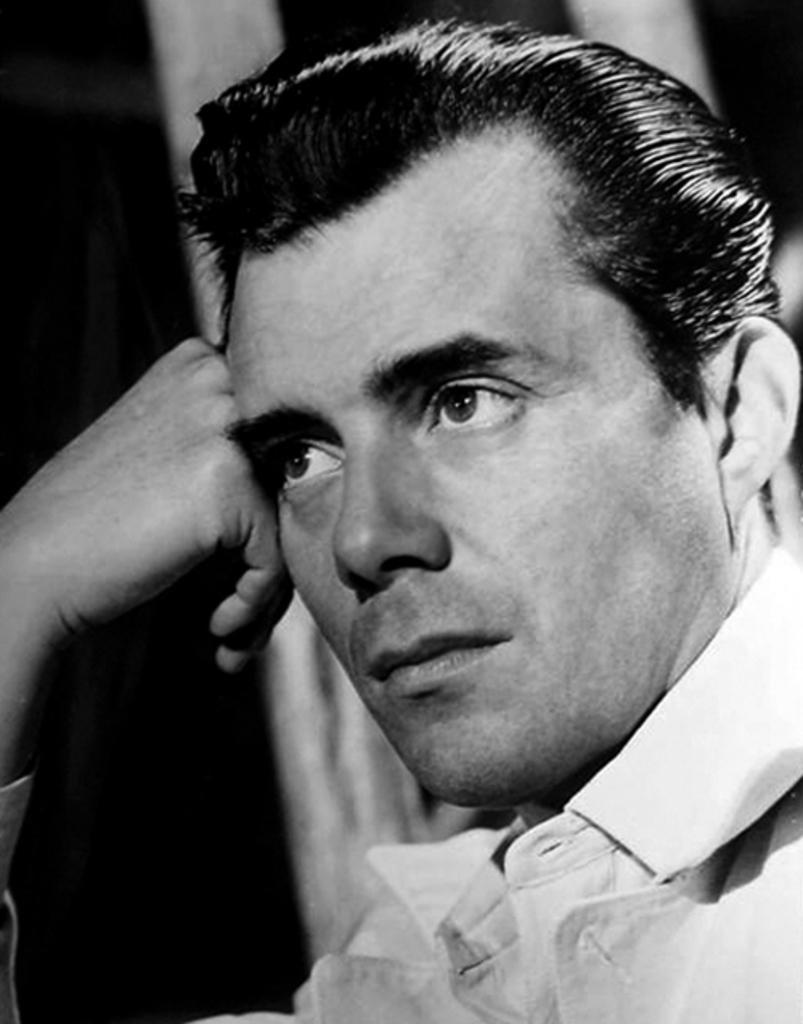Please provide a concise description of this image. In this picture we can see a man who is wearing shirt. Besides him we can see a wooden wall. 